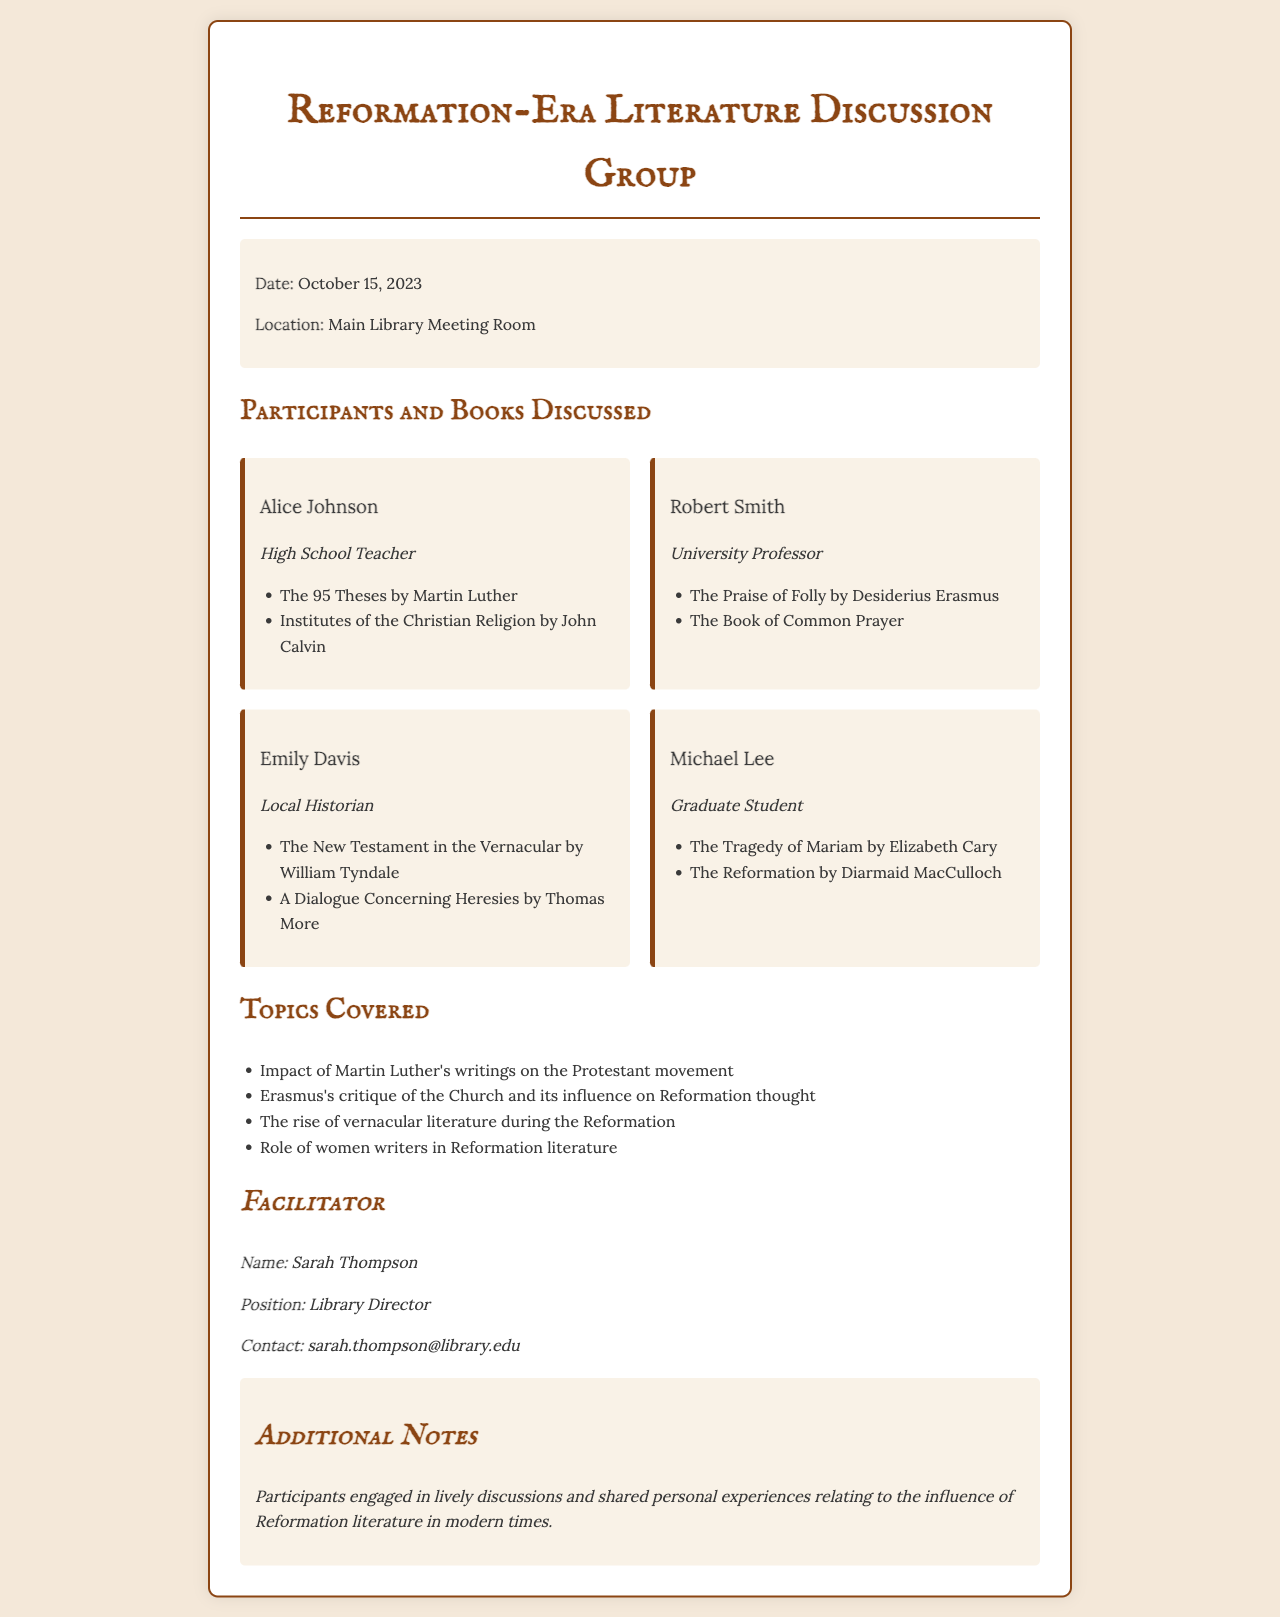What is the date of the discussion group? The date is mentioned in the event details section of the document as October 15, 2023.
Answer: October 15, 2023 Who facilitated the discussion? The facilitator’s name and position are listed under the facilitator section, indicating who led the discussion.
Answer: Sarah Thompson What was one of the books discussed by Alice Johnson? The document lists the books discussed by each participant, including Alice Johnson's selections.
Answer: The 95 Theses by Martin Luther What topic related to Erasmus was covered? The document outlines topics covered during the discussion, one of which directly pertains to Erasmus.
Answer: Erasmus's critique of the Church and its influence on Reformation thought How many participants were listed in the document? The participants section shows the number of individuals who attended the discussion.
Answer: Four What was the location of the discussion group? The event details specify the location where the discussion took place.
Answer: Main Library Meeting Room What role did Emily Davis have? Each participant's role is provided alongside their name in the document.
Answer: Local Historian What influence was discussed in relation to literature during the Reformation? The document details a specific topic regarding literature’s evolution during the Reformation period.
Answer: The rise of vernacular literature during the Reformation 